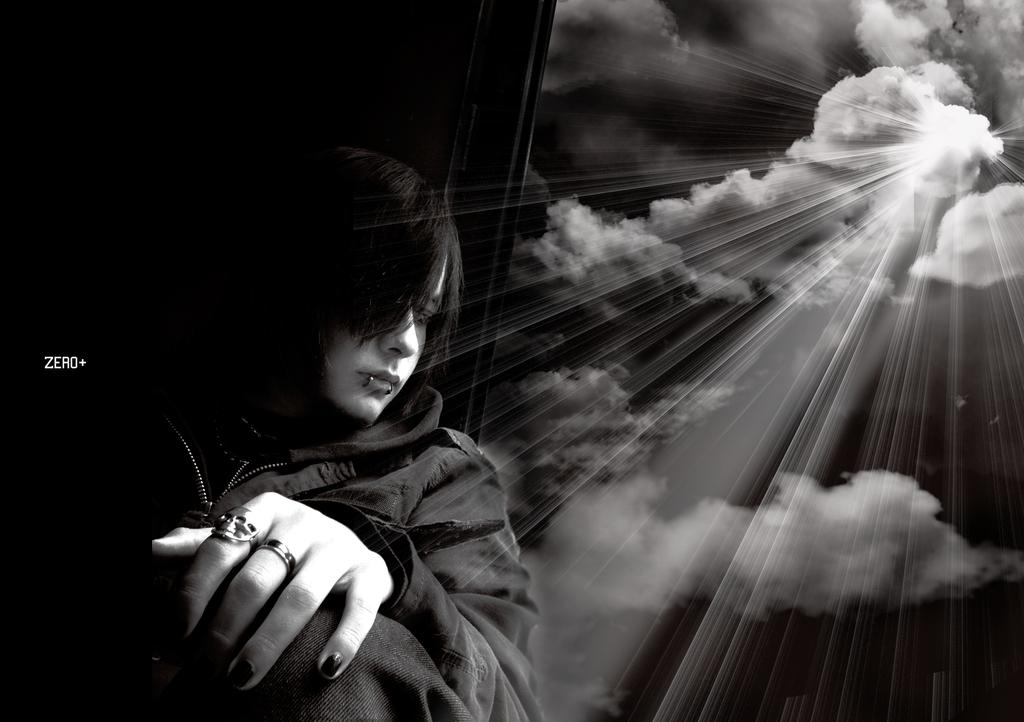Who or what is present in the image? There is a person in the image. What is the person wearing? The person is wearing a black dress. What can be seen in the sky in the image? There are clouds visible in the sky. How many crows are sitting on the gravestone in the image? There are no crows or gravestones present in the image. What type of paper is the person holding in the image? There is no paper visible in the image. 